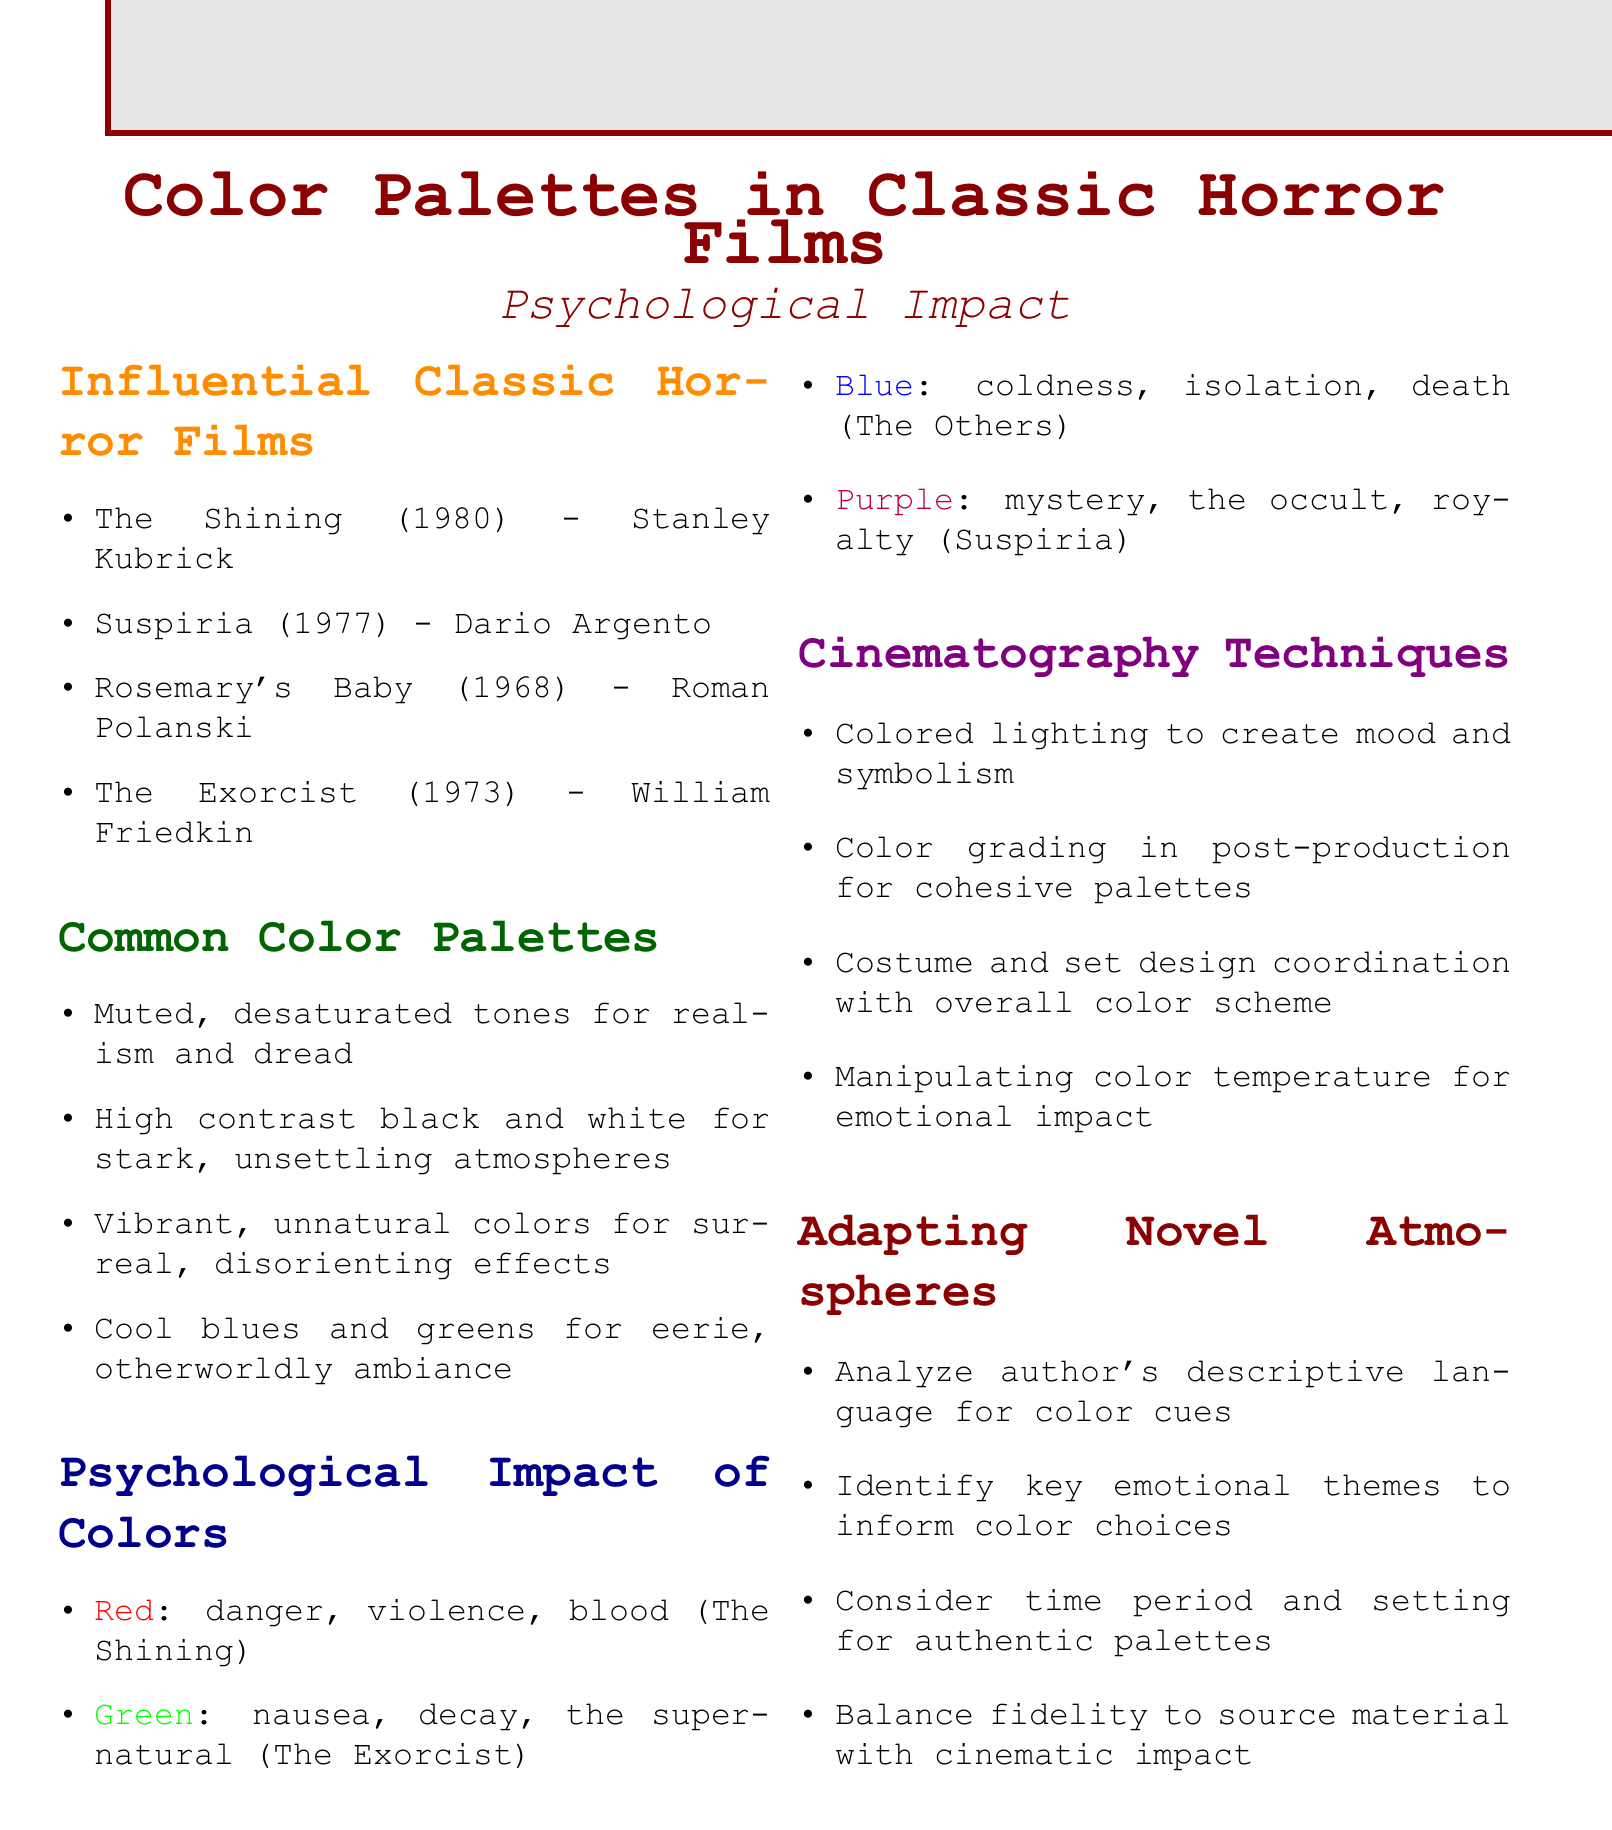What are some influential classic horror films? The document lists influential classic horror films in the section titled "Influential Classic Horror Films."
Answer: The Shining, Suspiria, Rosemary's Baby, The Exorcist What is a common color palette used in horror films? The section "Common Color Palettes" provides examples of color palettes commonly used in horror films.
Answer: Muted, desaturated tones What psychological impact does the color red have? The impact of red is described in the section "Psychological Impact of Colors."
Answer: Danger, violence, blood Which film is associated with the color green? The document identifies which films correspond with specific colors in the section "Psychological Impact of Colors."
Answer: The Exorcist What cinematography technique is used to create mood? The section "Cinematography Techniques" discusses methods used in cinematography.
Answer: Colored lighting What should be considered when adapting novel atmospheres? The section "Adapting Novel Atmospheres" outlines factors for adaptation.
Answer: Author's descriptive language How many classic horror films are listed in the document? Counting the films mentioned in the "Influential Classic Horror Films" section gives the total.
Answer: Four What color is associated with royalty in horror films? The document states the associations of colors in the "Psychological Impact of Colors" section.
Answer: Purple Which director made Rosemary's Baby? The film and its director are mentioned in the "Influential Classic Horror Films" section.
Answer: Roman Polanski What do cool blues and greens create in horror films? The "Common Color Palettes" section mentions the effects of these color tones.
Answer: Eerie, otherworldly ambiance 